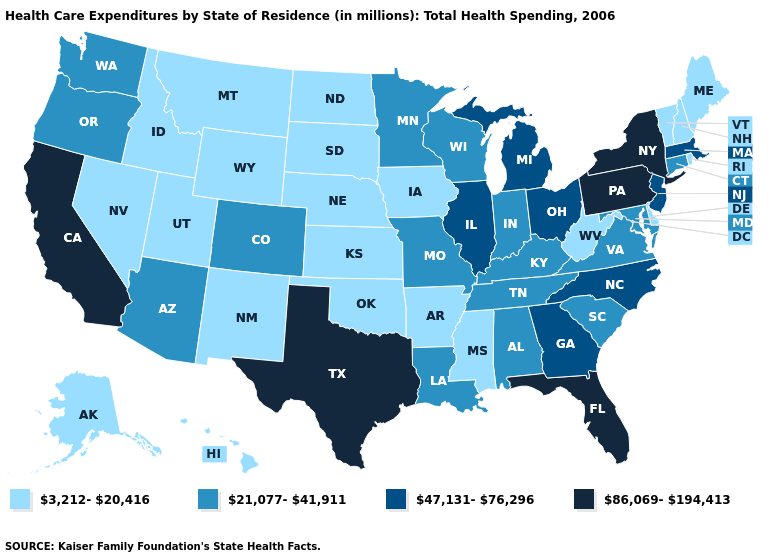What is the value of Massachusetts?
Quick response, please. 47,131-76,296. Which states have the highest value in the USA?
Give a very brief answer. California, Florida, New York, Pennsylvania, Texas. What is the lowest value in the USA?
Write a very short answer. 3,212-20,416. What is the value of Colorado?
Short answer required. 21,077-41,911. What is the lowest value in the Northeast?
Be succinct. 3,212-20,416. Is the legend a continuous bar?
Be succinct. No. Among the states that border Nevada , does Idaho have the lowest value?
Answer briefly. Yes. Name the states that have a value in the range 86,069-194,413?
Concise answer only. California, Florida, New York, Pennsylvania, Texas. Does Texas have a higher value than Tennessee?
Concise answer only. Yes. Which states have the lowest value in the USA?
Keep it brief. Alaska, Arkansas, Delaware, Hawaii, Idaho, Iowa, Kansas, Maine, Mississippi, Montana, Nebraska, Nevada, New Hampshire, New Mexico, North Dakota, Oklahoma, Rhode Island, South Dakota, Utah, Vermont, West Virginia, Wyoming. Which states have the lowest value in the South?
Be succinct. Arkansas, Delaware, Mississippi, Oklahoma, West Virginia. Does Vermont have the lowest value in the USA?
Concise answer only. Yes. Does Arkansas have the lowest value in the USA?
Short answer required. Yes. Is the legend a continuous bar?
Keep it brief. No. 